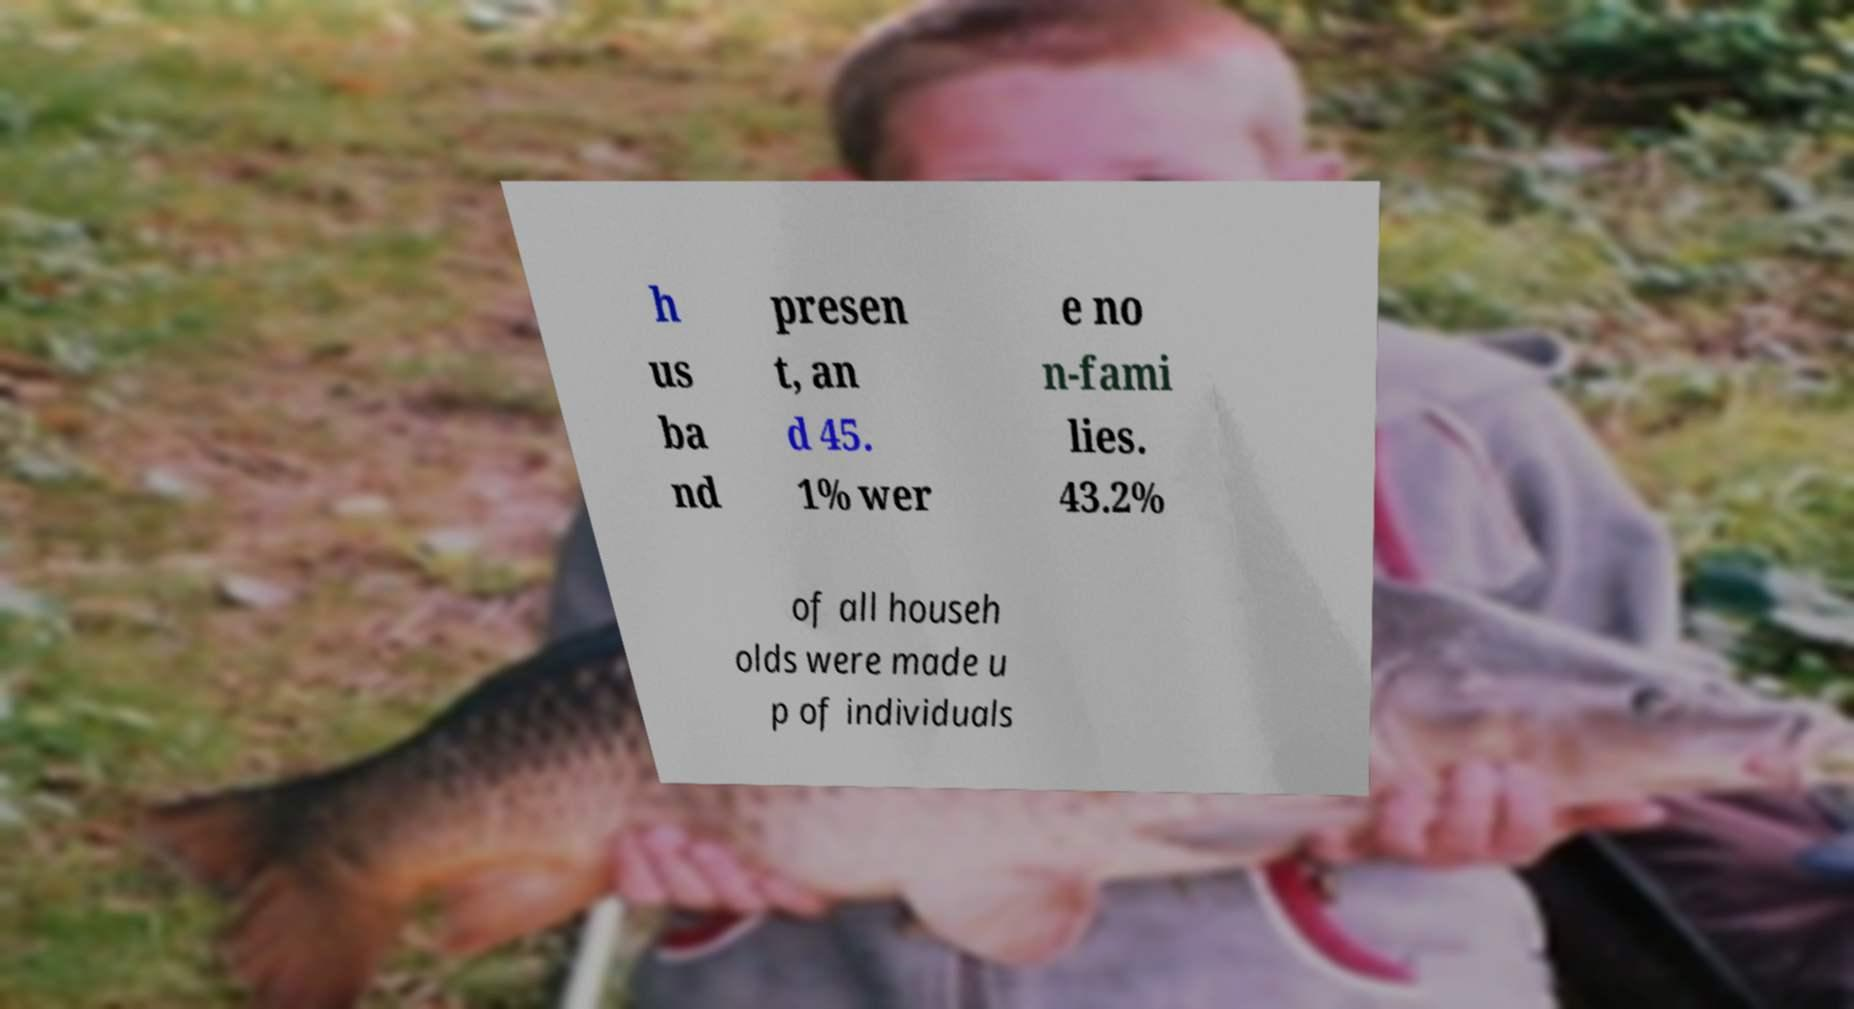What messages or text are displayed in this image? I need them in a readable, typed format. h us ba nd presen t, an d 45. 1% wer e no n-fami lies. 43.2% of all househ olds were made u p of individuals 